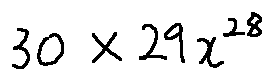<formula> <loc_0><loc_0><loc_500><loc_500>3 0 \times 2 9 x ^ { 2 8 }</formula> 